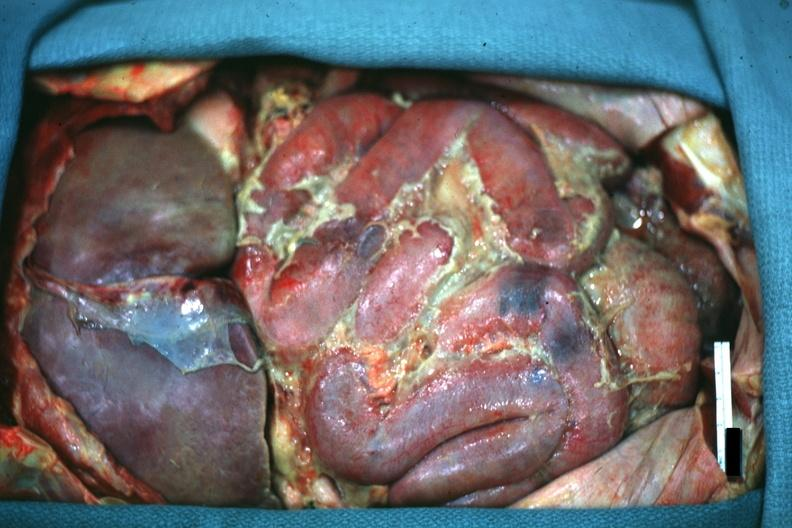where is this area in the body?
Answer the question using a single word or phrase. Abdomen 